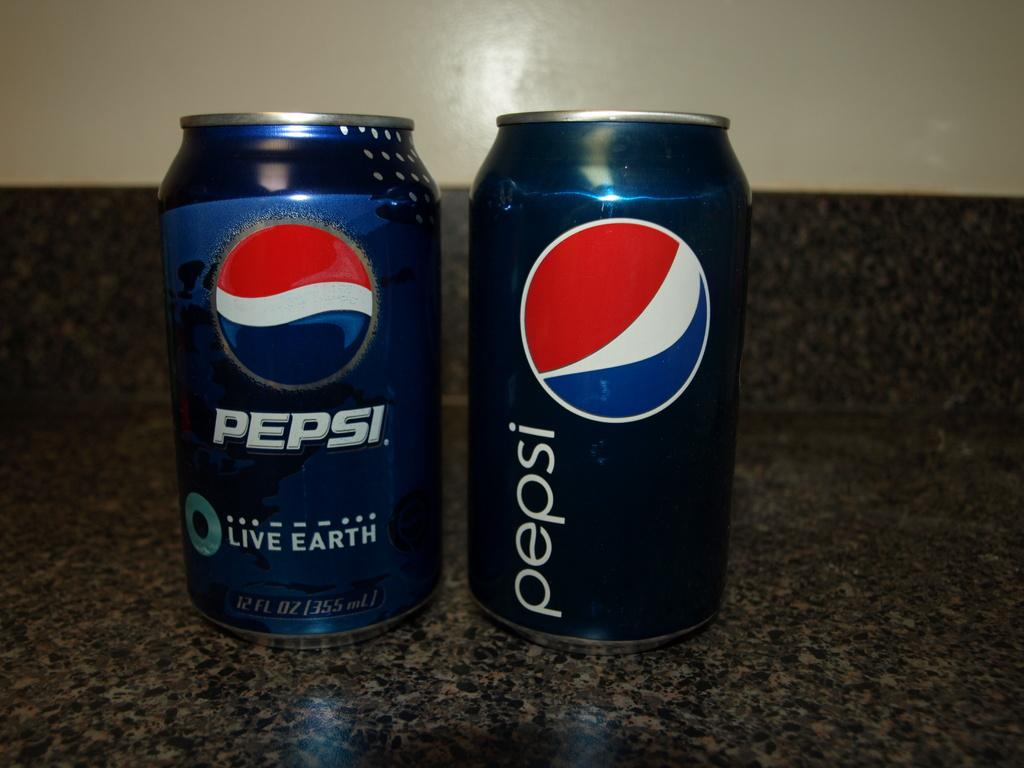Provide a one-sentence caption for the provided image. Two Pepsi cans on top of a counter with one saying "Live Earth". 